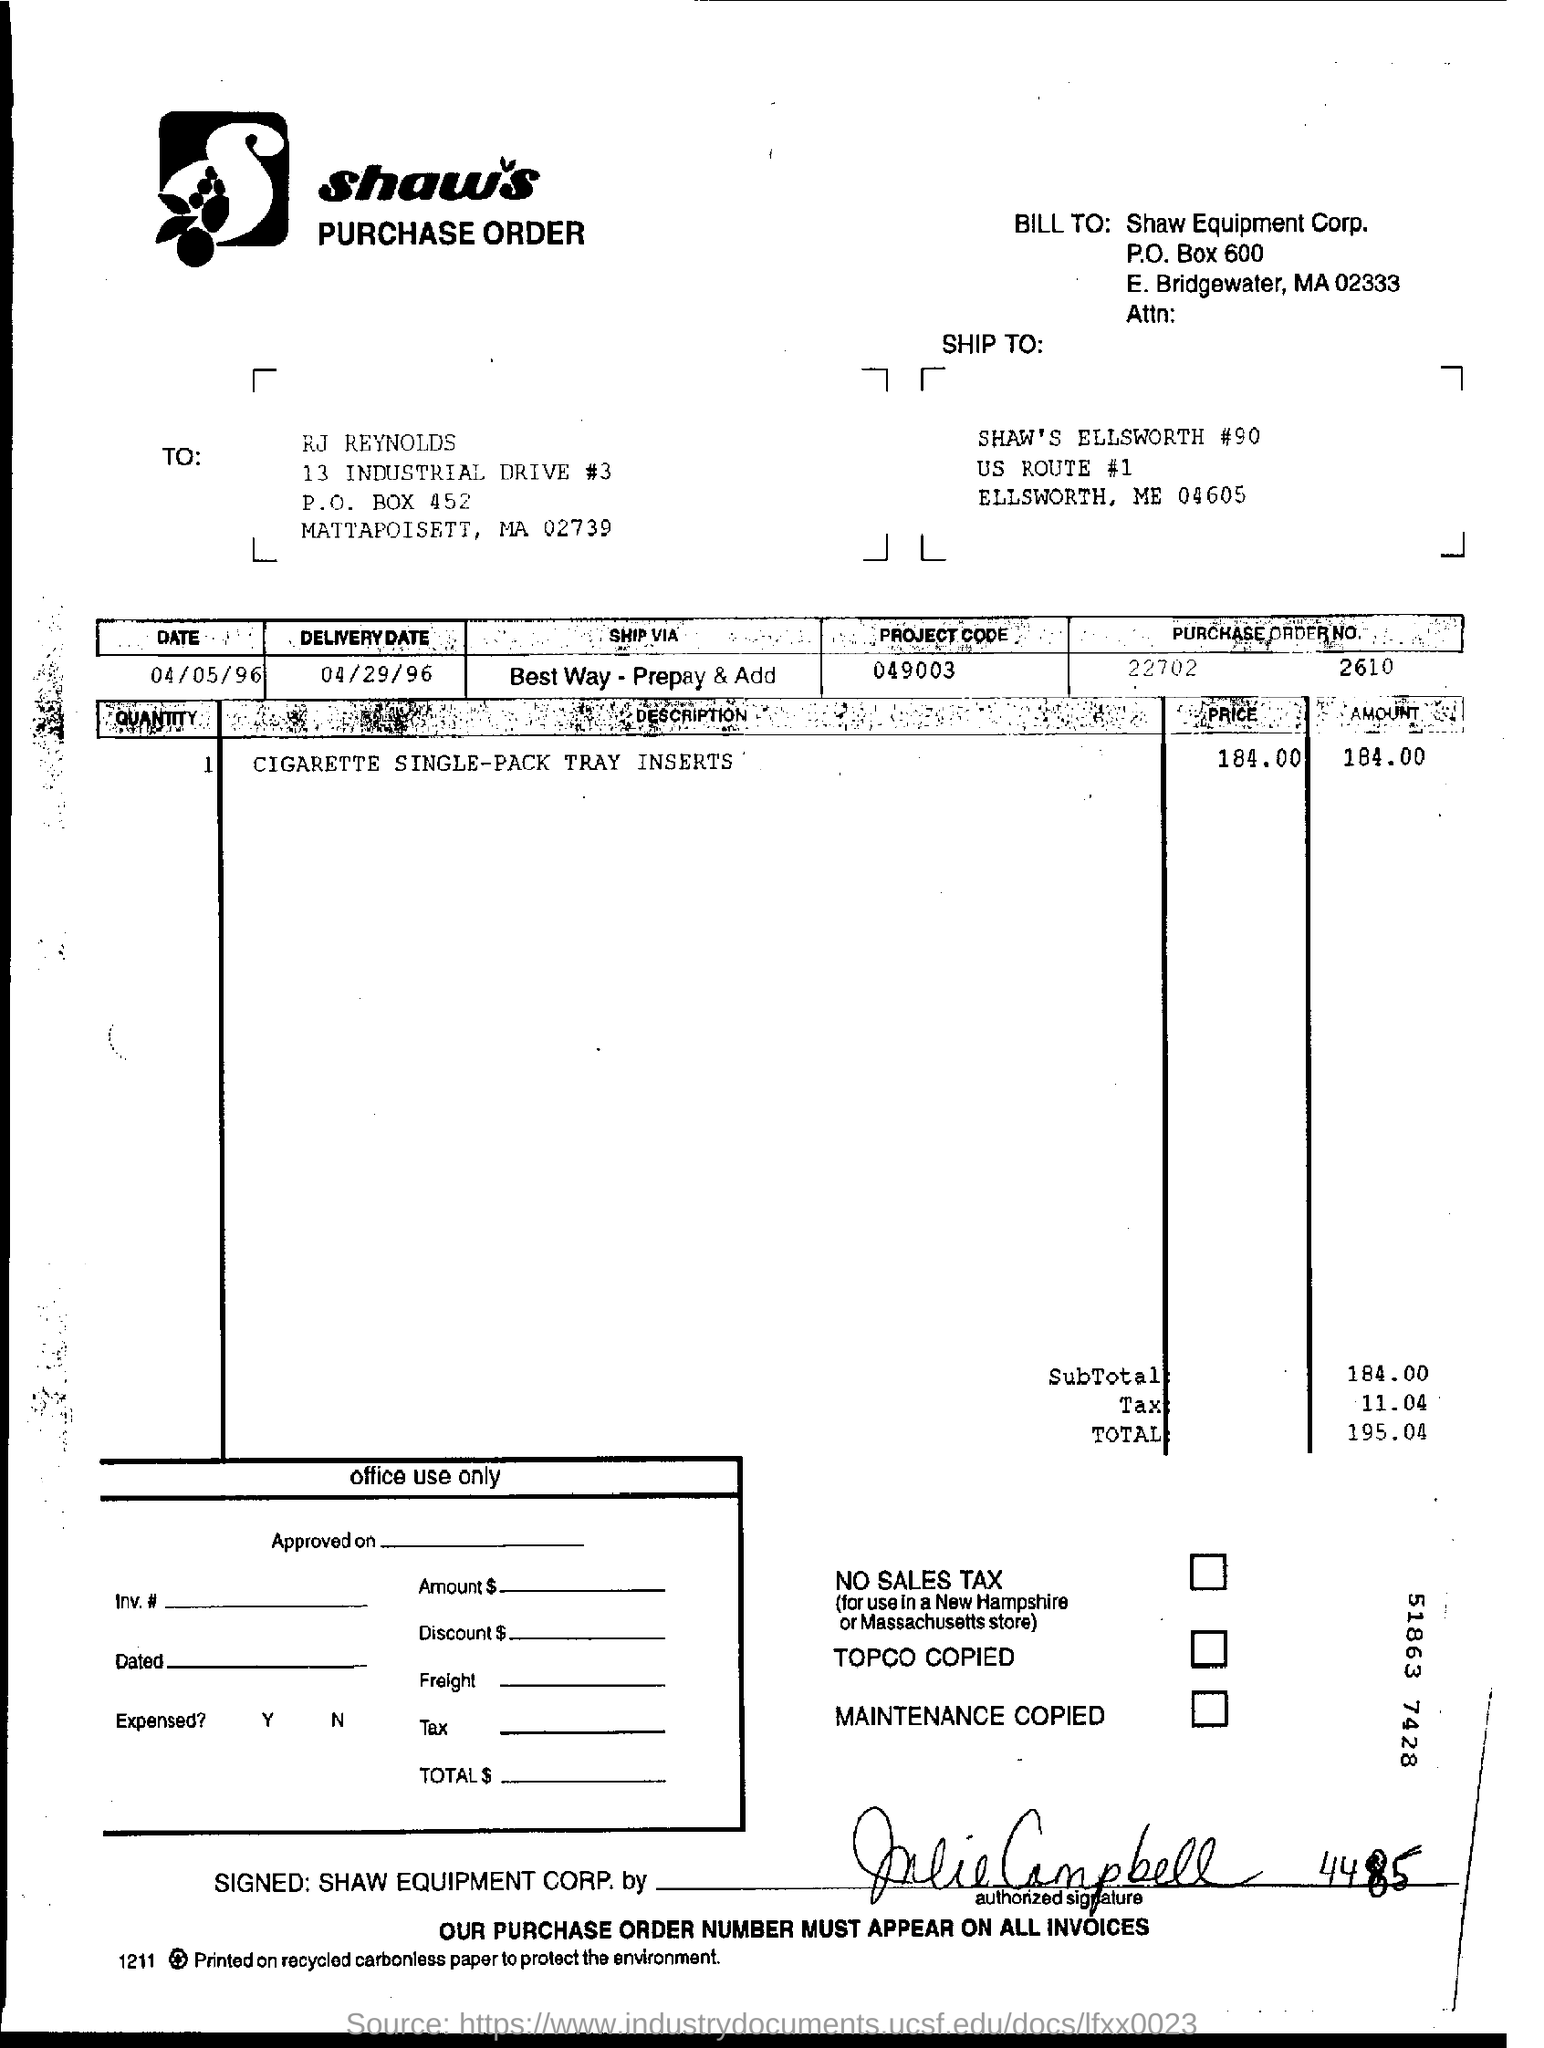Point out several critical features in this image. The purchase order number is 22702, and it was issued on October 2610. On what date was the delivery made? The subtotal is 184.00. The project code for 049003... is... The total amount of the bill is 195.04. 